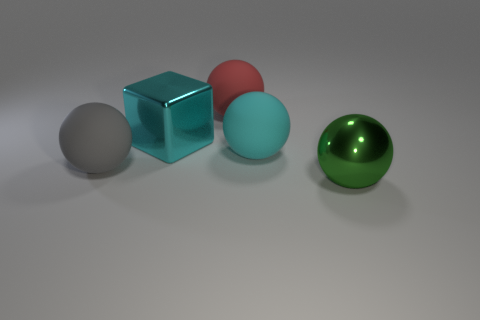Is the number of cyan shiny blocks on the right side of the block greater than the number of large red matte things that are on the right side of the cyan rubber object?
Offer a very short reply. No. There is a metal cube; is it the same color as the thing to the left of the cyan shiny thing?
Your response must be concise. No. There is a cyan ball that is the same size as the green metallic ball; what is it made of?
Ensure brevity in your answer.  Rubber. What number of objects are either green balls or rubber spheres right of the red rubber ball?
Make the answer very short. 2. Is the size of the green shiny ball the same as the metallic object that is behind the gray rubber ball?
Provide a succinct answer. Yes. What number of spheres are either large red matte objects or large gray rubber things?
Provide a short and direct response. 2. How many large shiny objects are both on the right side of the big red object and behind the large cyan ball?
Your answer should be compact. 0. What number of other objects are there of the same color as the metallic ball?
Provide a short and direct response. 0. What is the shape of the shiny thing that is behind the green shiny sphere?
Your response must be concise. Cube. Is the material of the cyan ball the same as the red ball?
Offer a very short reply. Yes. 